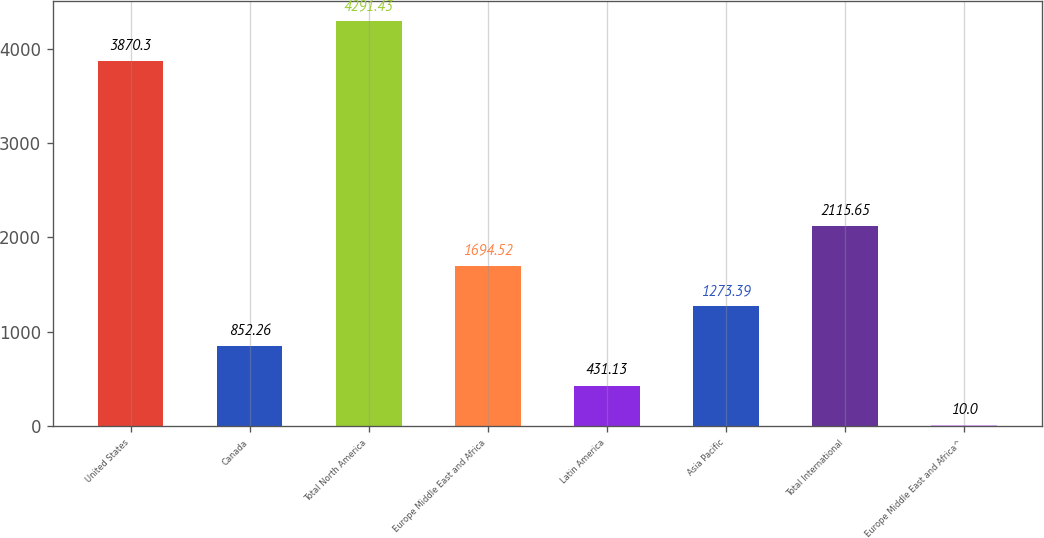Convert chart to OTSL. <chart><loc_0><loc_0><loc_500><loc_500><bar_chart><fcel>United States<fcel>Canada<fcel>Total North America<fcel>Europe Middle East and Africa<fcel>Latin America<fcel>Asia Pacific<fcel>Total International<fcel>Europe Middle East and Africa^<nl><fcel>3870.3<fcel>852.26<fcel>4291.43<fcel>1694.52<fcel>431.13<fcel>1273.39<fcel>2115.65<fcel>10<nl></chart> 